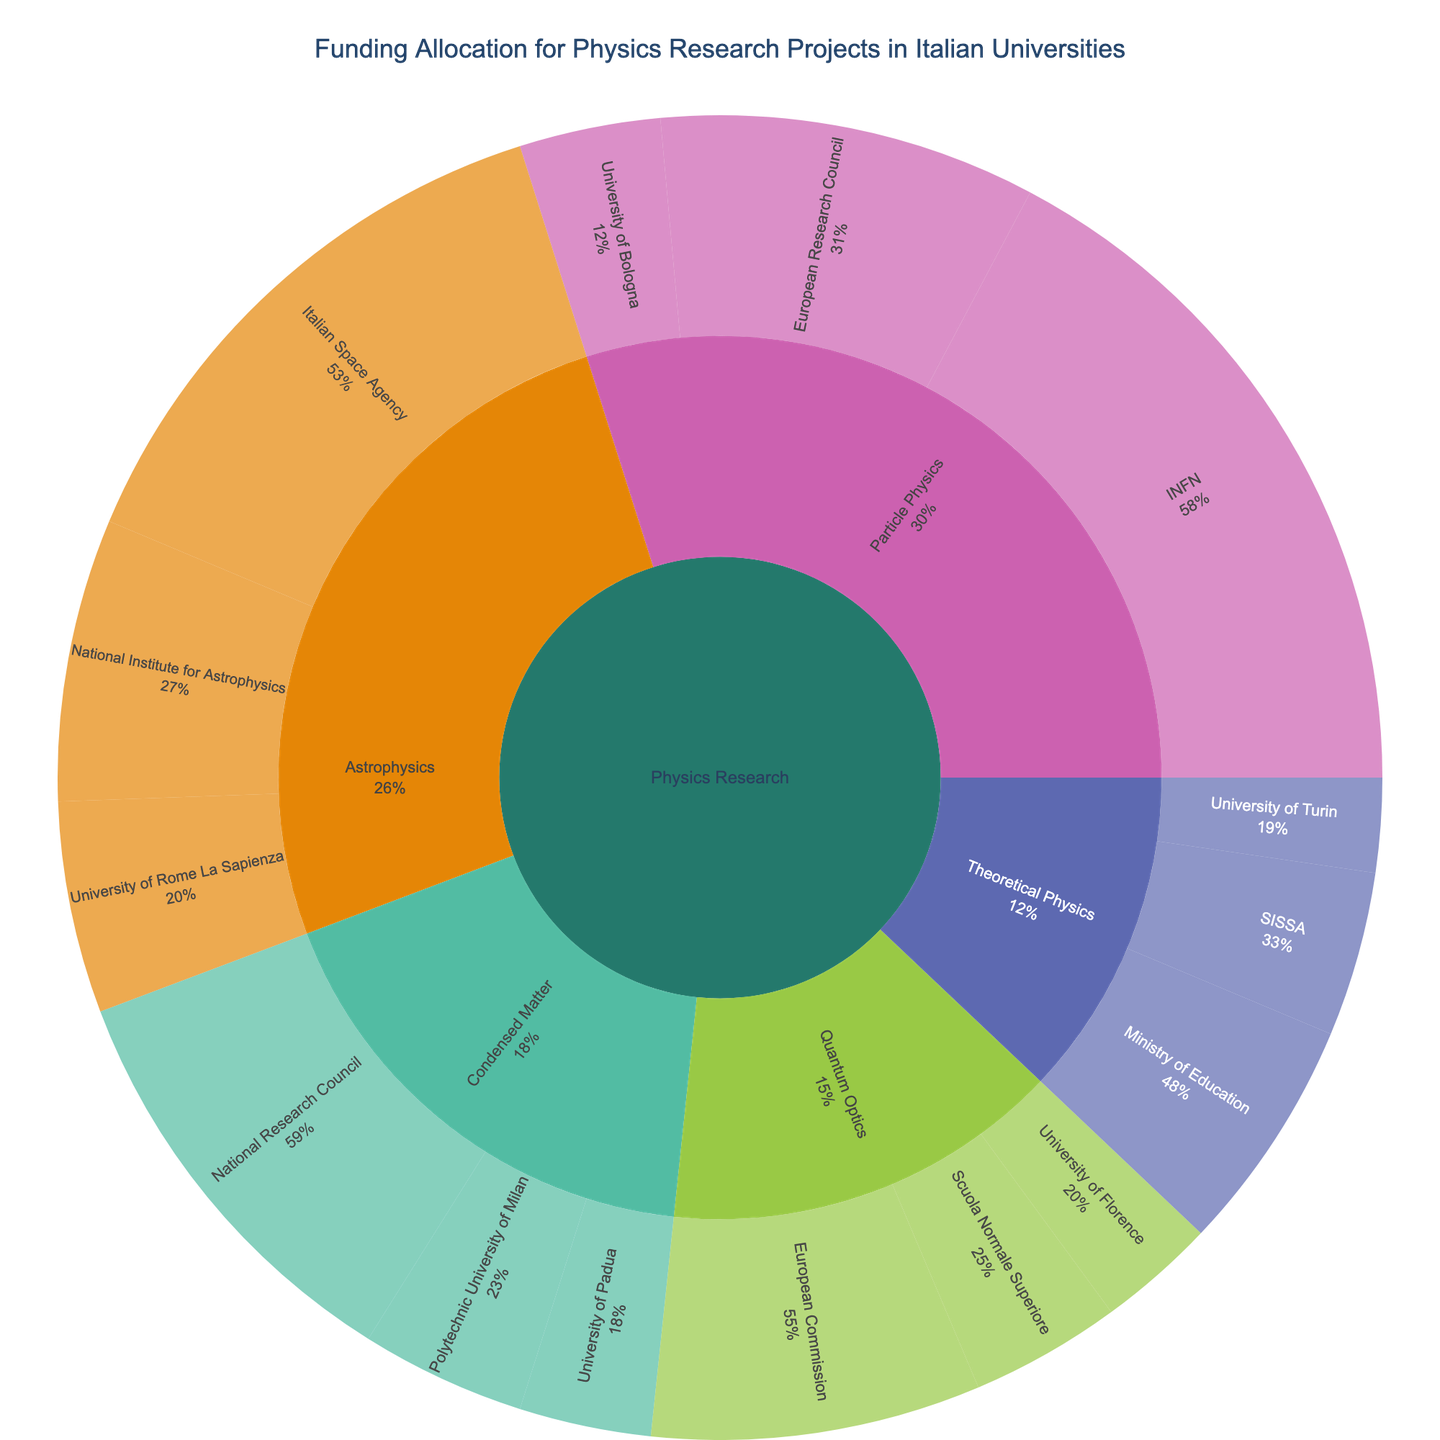What is the total funding allocated for Particle Physics? To determine the total funding for Particle Physics, sum up the values for the subcategories under Particle Physics: INFN (15,000,000 €), European Research Council (8,000,000 €), and University of Bologna (3,000,000 €).
Answer: 26,000,000 € What percentage of the total funding does Quantum Optics receive? The total funding across all subcategories is calculated by summing all the values: Particle Physics (26,000,000 €), Astrophysics (22,500,000 €), Condensed Matter (15,300,000 €), Quantum Optics (12,700,000 €), Theoretical Physics (10,500,000 €). The total is 87,000,000 €. Quantum Optics funding is 12,700,000 €. The percentage is (12,700,000 € / 87,000,000 €) * 100.
Answer: 14.6% Which subcategory receives the most funding? By examining the funding amounts for each subcategory, Particle Physics receives the highest funding with a total sum of 26,000,000 €.
Answer: Particle Physics How much more funding does Astrophysics receive compared to Theoretical Physics? Calculate the difference between Astrophysics (22,500,000 €) and Theoretical Physics (10,500,000 €).
Answer: 12,000,000 € What is the funding distribution between the National Institute for Astrophysics and the University of Rome La Sapienza under Astrophysics? The National Institute for Astrophysics receives 6,000,000 €, and the University of Rome La Sapienza receives 4,500,000 €.
Answer: 6,000,000 € and 4,500,000 € Which funding source provides the highest amount for a single subcategory, and what is the amount? Look at the highest funding amounts listed under each subcategory in the plot. INFN provides the highest amount for Particle Physics with 15,000,000 €.
Answer: INFN, 15,000,000 € What is the average funding provided per subcategory in Condensed Matter? Calculate the average by summing the Condensed Matter values (9,000,000 €, 3,500,000 €, and 2,800,000 €) and dividing by the number of subcategories (3).
Answer: 5,766,667 € Out of all the research areas, which one has the least amount of funding and what is the amount? By comparing the total funding for each research area, Quantum Optics has the least amount with 12,700,000 €.
Answer: Quantum Optics, 12,700,000 € How does funding from the European Research Council compare between Particle Physics and Quantum Optics? Compare the amounts given: European Research Council funds Particle Physics with 8,000,000 € and Quantum Optics with 7,000,000 €.
Answer: Particle Physics, 8,000,000 €; Quantum Optics, 7,000,000 € What is the sum of all university-provided funding across all subcategories? Add the funding provided by universities: University of Bologna (3,000,000 €), University of Rome La Sapienza (4,500,000 €), Polytechnic University of Milan (3,500,000 €), University of Padua (2,800,000 €), University of Florence (2,500,000 €), and University of Turin (2,000,000 €).
Answer: 18,300,000 € 